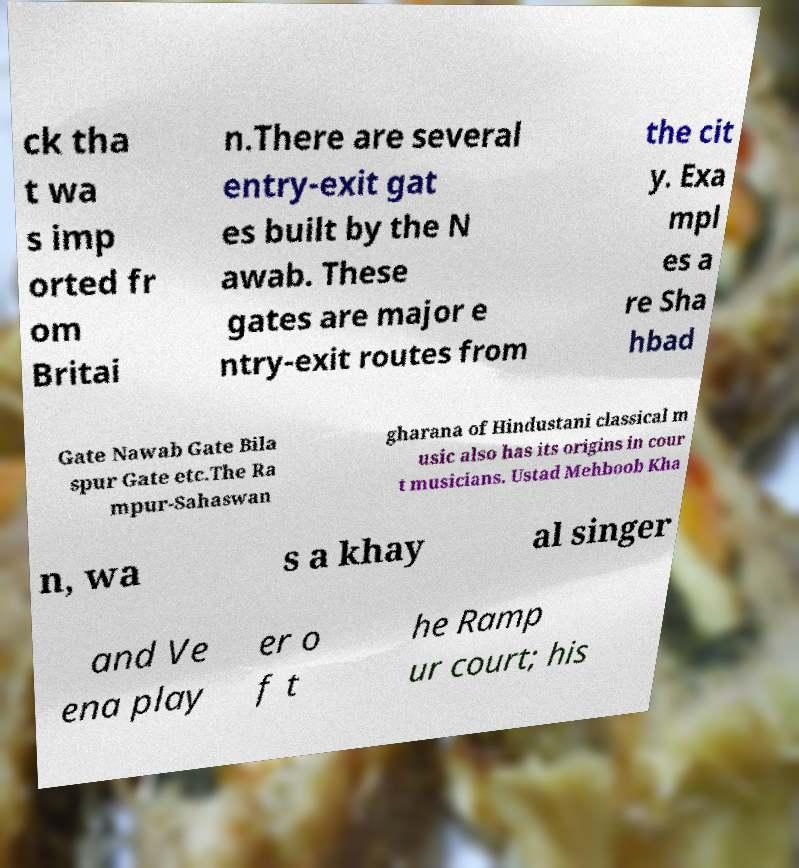I need the written content from this picture converted into text. Can you do that? ck tha t wa s imp orted fr om Britai n.There are several entry-exit gat es built by the N awab. These gates are major e ntry-exit routes from the cit y. Exa mpl es a re Sha hbad Gate Nawab Gate Bila spur Gate etc.The Ra mpur-Sahaswan gharana of Hindustani classical m usic also has its origins in cour t musicians. Ustad Mehboob Kha n, wa s a khay al singer and Ve ena play er o f t he Ramp ur court; his 